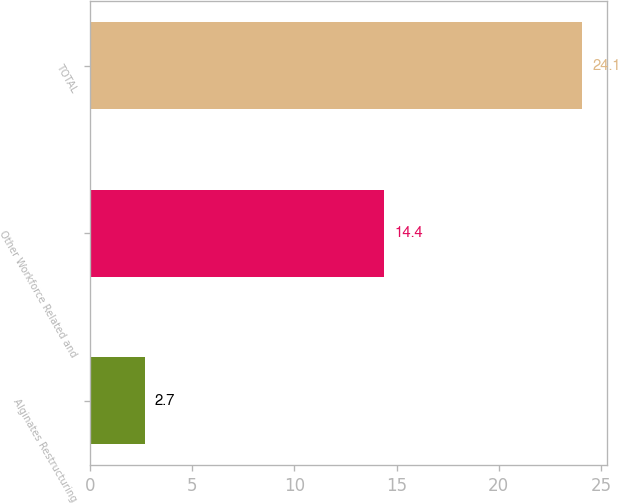Convert chart. <chart><loc_0><loc_0><loc_500><loc_500><bar_chart><fcel>Alginates Restructuring<fcel>Other Workforce Related and<fcel>TOTAL<nl><fcel>2.7<fcel>14.4<fcel>24.1<nl></chart> 